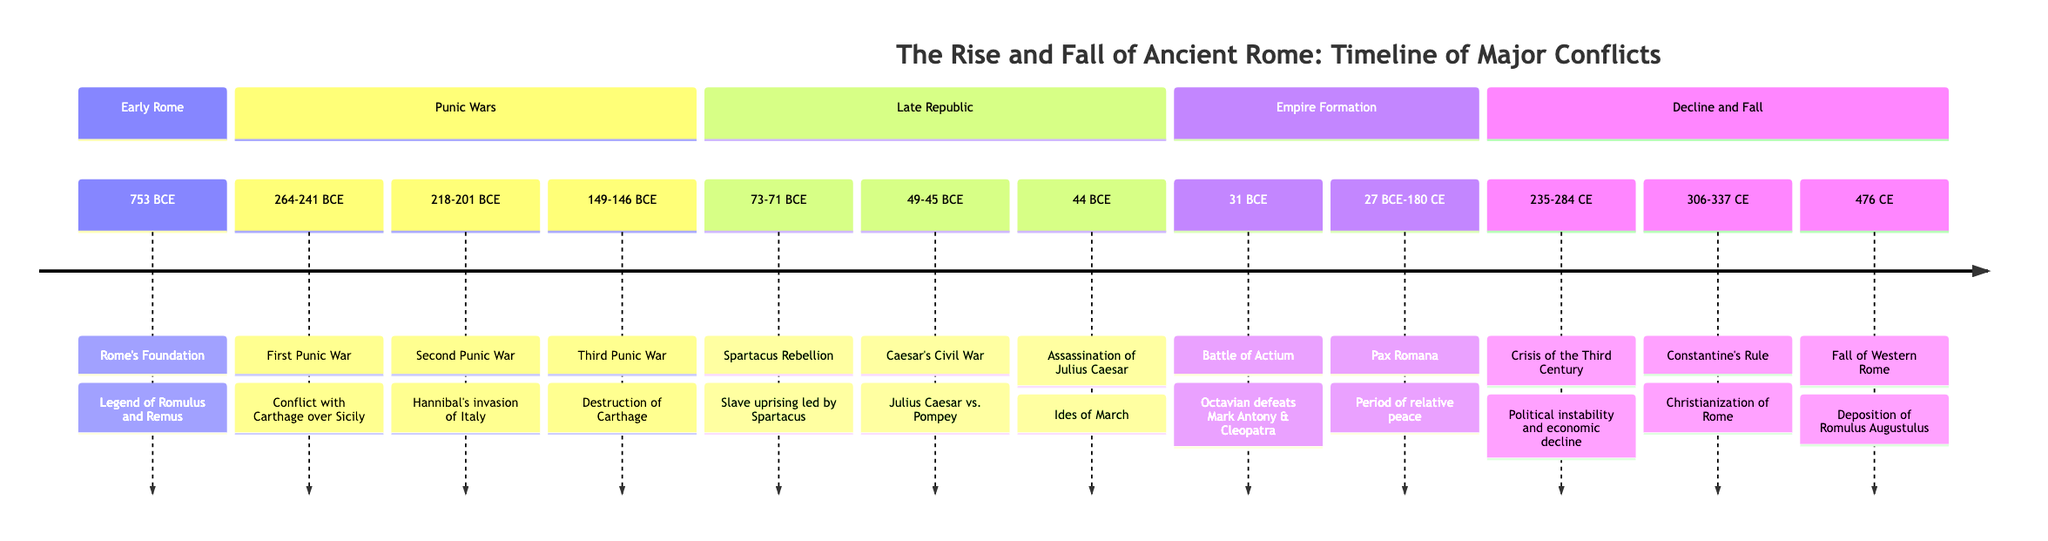What is the start date of the First Punic War? The diagram states the First Punic War occurred from 264-241 BCE. Therefore, the start date is the first year mentioned, which is 264 BCE.
Answer: 264 BCE How many major conflicts are listed in the timeline? By counting each event in the diagram, there are a total of 11 major conflicts listed.
Answer: 11 What significant event took place in 44 BCE? According to the diagram, the event listed for 44 BCE is the Assassination of Julius Caesar, which is emphasized as a notable occurrence.
Answer: Assassination of Julius Caesar Which conflict is associated with Hannibal? The diagram indicates that Hannibal is connected to the Second Punic War, which is specifically mentioned as his invasion of Italy during 218-201 BCE.
Answer: Second Punic War What period does the Pax Romana cover? The diagram shows that the Pax Romana is outlined as occurring from 27 BCE to 180 CE, indicating a range of years that can be interpreted directly from the timeline.
Answer: 27 BCE-180 CE Which section includes the Spartacus Rebellion? The Spartacus Rebellion is mentioned under the Late Republic section of the diagram, highlighting its positional significance within that timeframe.
Answer: Late Republic What event concluded the Western Roman Empire? The diagram indicates that the Fall of Western Rome occurred in 476 CE, signaling the end of that empire.
Answer: Fall of Western Rome What was the political situation during 235-284 CE? The Crisis of the Third Century is presented in the diagram for this time frame, highlighting political instability and economic decline as major issues.
Answer: Crisis of the Third Century Who defeated Mark Antony and Cleopatra? According to the diagram, Octavian defeated Mark Antony and Cleopatra in the Battle of Actium in 31 BCE, marking a significant event in Rome's history.
Answer: Octavian 